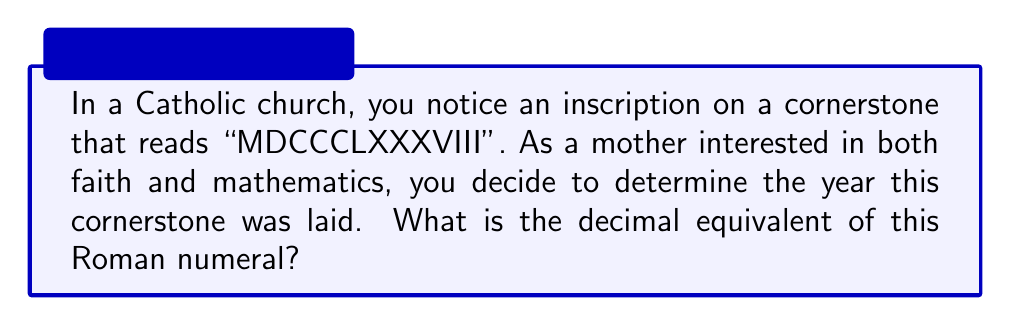Give your solution to this math problem. To convert Roman numerals to decimal numbers, we need to understand the value of each symbol and the rules for combining them. Let's break down the process:

1. Roman numeral symbols and their decimal values:
   $I = 1$, $V = 5$, $X = 10$, $L = 50$, $C = 100$, $D = 500$, $M = 1000$

2. Rules for combining:
   - Generally, symbols are added from left to right
   - When a smaller value precedes a larger value, it is subtracted

3. Breaking down MDCCCLXXXVIII:
   $M = 1000$
   $DCCC = 500 + 100 + 100 + 100 = 800$
   $LXXX = 50 + 10 + 10 + 10 = 80$
   $VIII = 5 + 1 + 1 + 1 = 8$

4. Adding the values:
   $$1000 + 800 + 80 + 8 = 1888$$

Therefore, the cornerstone was laid in the year 1888 AD.
Answer: 1888 